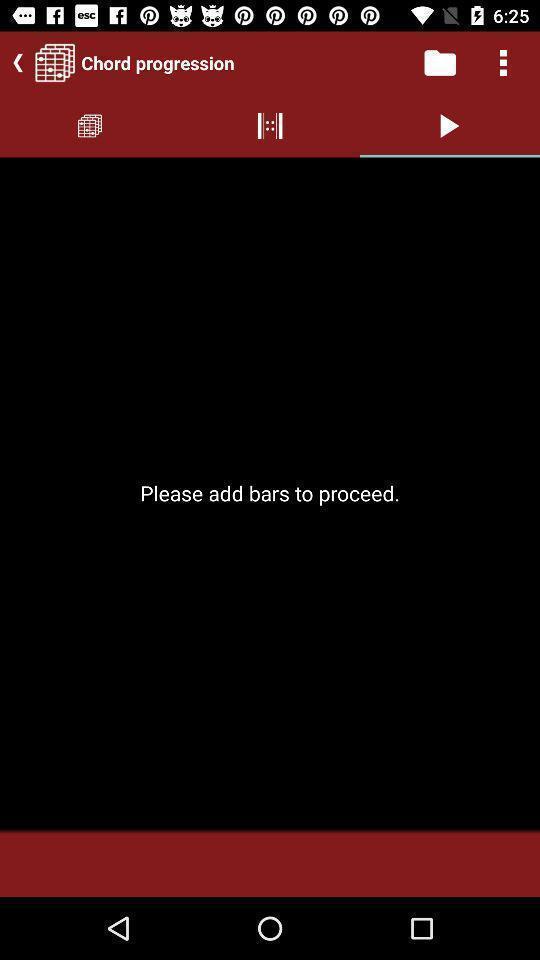Describe this image in words. Page displaying option to add bars in music application. 